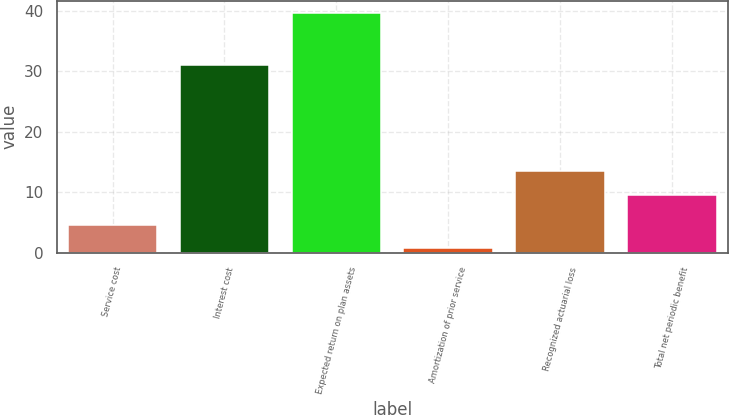Convert chart to OTSL. <chart><loc_0><loc_0><loc_500><loc_500><bar_chart><fcel>Service cost<fcel>Interest cost<fcel>Expected return on plan assets<fcel>Amortization of prior service<fcel>Recognized actuarial loss<fcel>Total net periodic benefit<nl><fcel>4.69<fcel>31.1<fcel>39.7<fcel>0.8<fcel>13.49<fcel>9.6<nl></chart> 